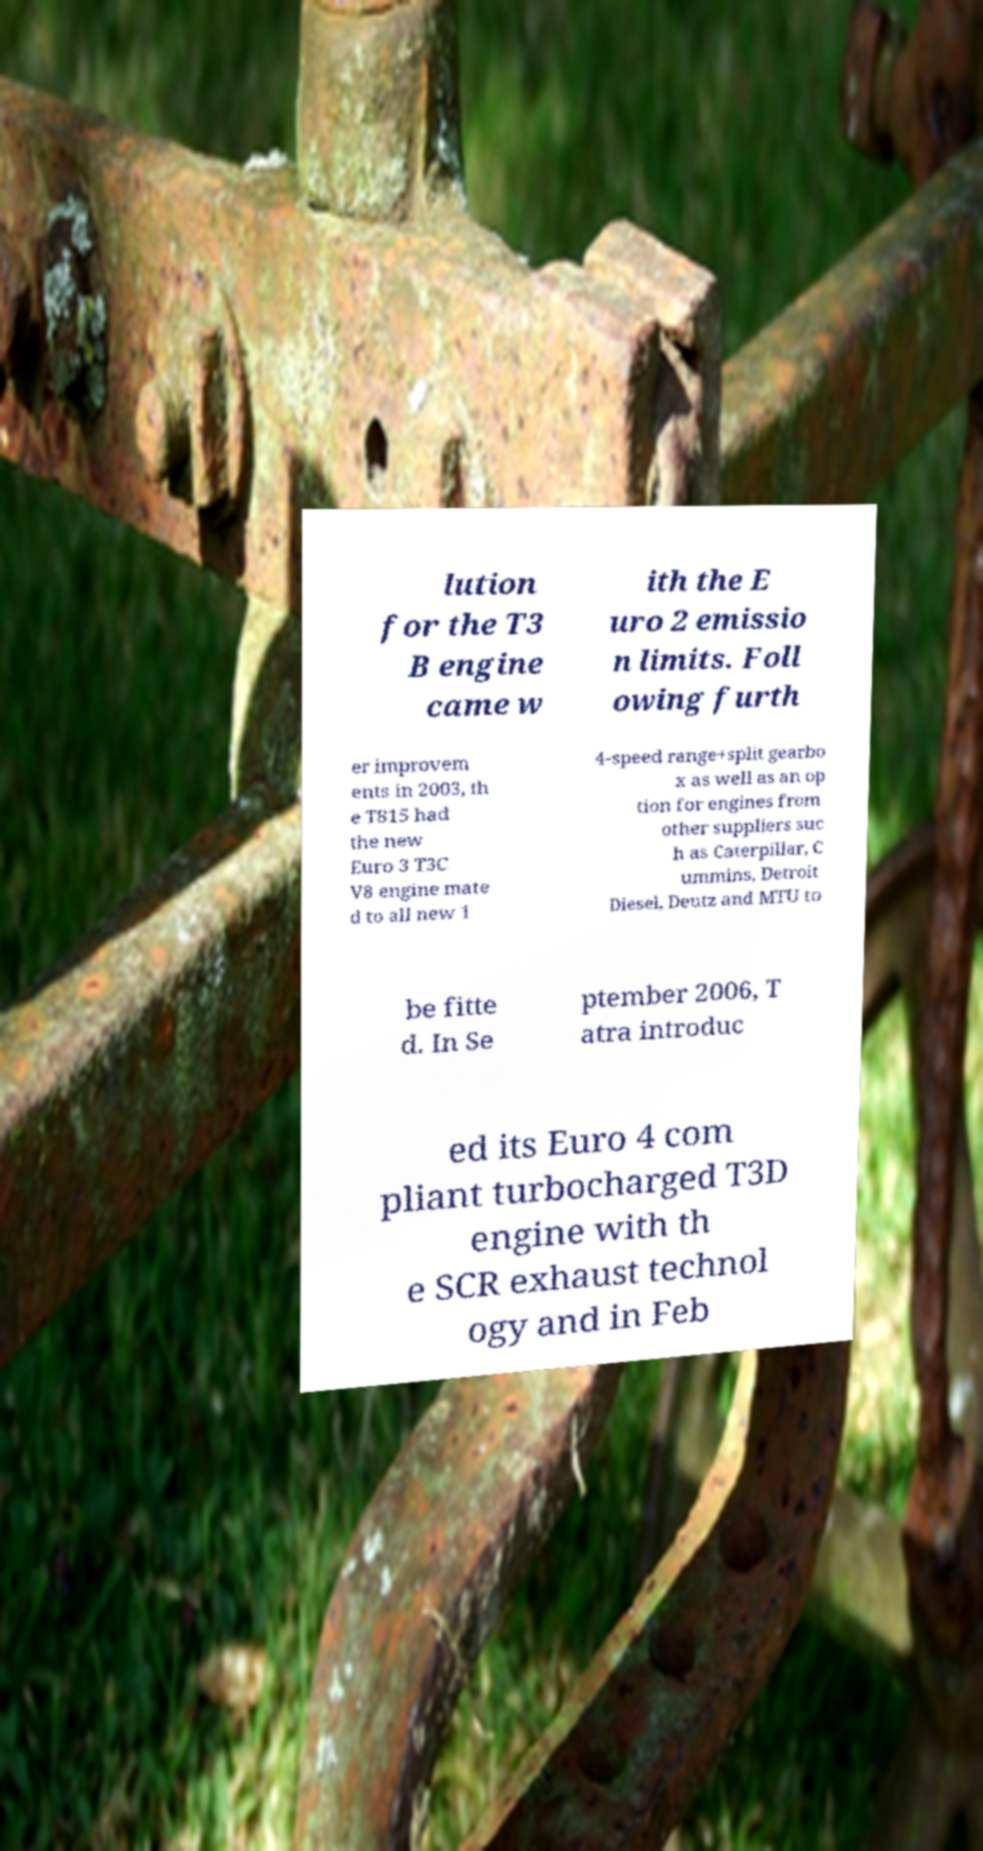Can you accurately transcribe the text from the provided image for me? lution for the T3 B engine came w ith the E uro 2 emissio n limits. Foll owing furth er improvem ents in 2003, th e T815 had the new Euro 3 T3C V8 engine mate d to all new 1 4-speed range+split gearbo x as well as an op tion for engines from other suppliers suc h as Caterpillar, C ummins, Detroit Diesel, Deutz and MTU to be fitte d. In Se ptember 2006, T atra introduc ed its Euro 4 com pliant turbocharged T3D engine with th e SCR exhaust technol ogy and in Feb 